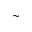Convert formula to latex. <formula><loc_0><loc_0><loc_500><loc_500>\sim</formula> 